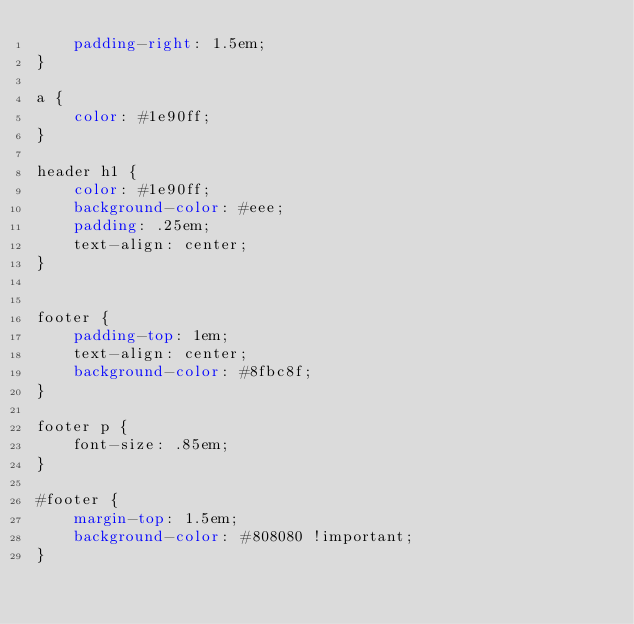Convert code to text. <code><loc_0><loc_0><loc_500><loc_500><_CSS_>    padding-right: 1.5em;
}

a {
    color: #1e90ff;
}

header h1 {
    color: #1e90ff;
    background-color: #eee;
    padding: .25em;
    text-align: center;
}


footer {
    padding-top: 1em;
    text-align: center;
    background-color: #8fbc8f;
}

footer p {
    font-size: .85em;
}

#footer {
    margin-top: 1.5em;
    background-color: #808080 !important;
}
</code> 